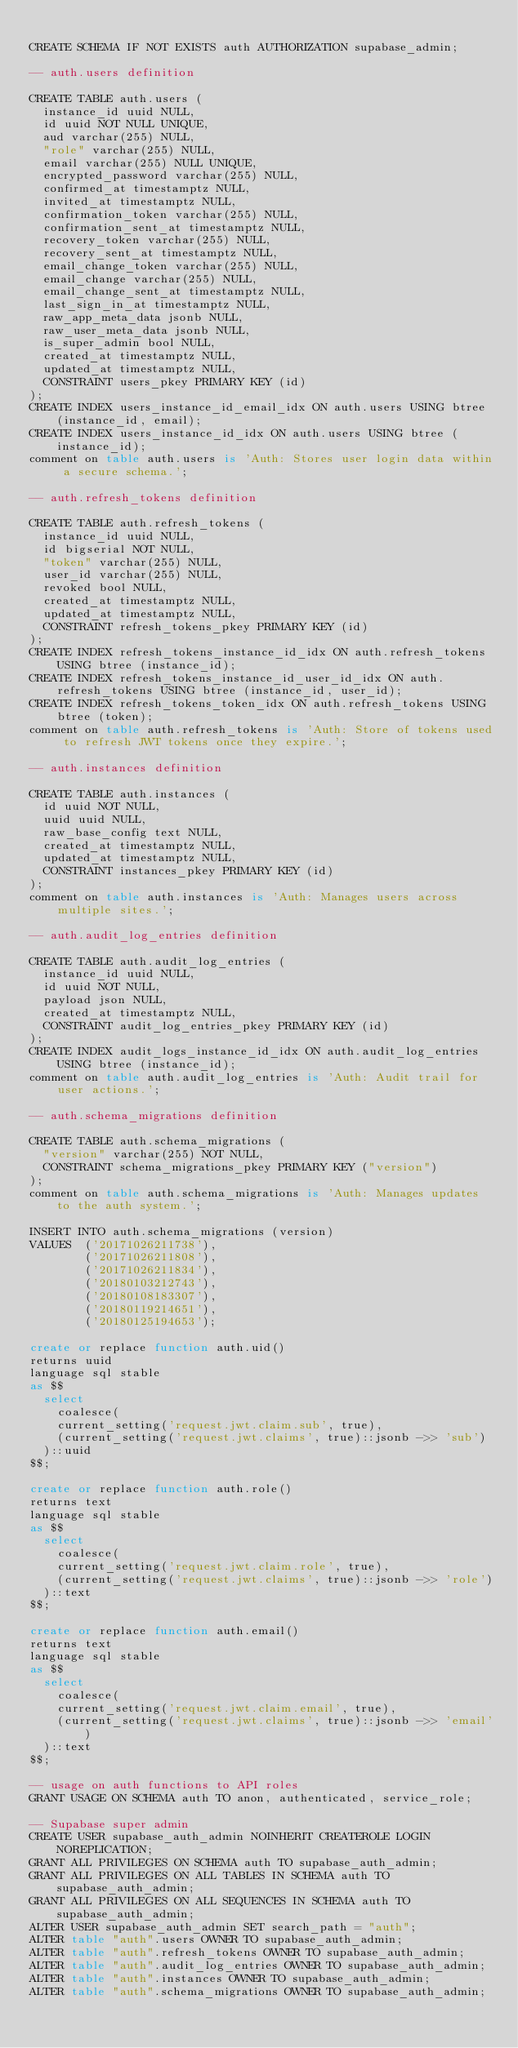<code> <loc_0><loc_0><loc_500><loc_500><_SQL_>
CREATE SCHEMA IF NOT EXISTS auth AUTHORIZATION supabase_admin;

-- auth.users definition

CREATE TABLE auth.users (
	instance_id uuid NULL,
	id uuid NOT NULL UNIQUE,
	aud varchar(255) NULL,
	"role" varchar(255) NULL,
	email varchar(255) NULL UNIQUE,
	encrypted_password varchar(255) NULL,
	confirmed_at timestamptz NULL,
	invited_at timestamptz NULL,
	confirmation_token varchar(255) NULL,
	confirmation_sent_at timestamptz NULL,
	recovery_token varchar(255) NULL,
	recovery_sent_at timestamptz NULL,
	email_change_token varchar(255) NULL,
	email_change varchar(255) NULL,
	email_change_sent_at timestamptz NULL,
	last_sign_in_at timestamptz NULL,
	raw_app_meta_data jsonb NULL,
	raw_user_meta_data jsonb NULL,
	is_super_admin bool NULL,
	created_at timestamptz NULL,
	updated_at timestamptz NULL,
	CONSTRAINT users_pkey PRIMARY KEY (id)
);
CREATE INDEX users_instance_id_email_idx ON auth.users USING btree (instance_id, email);
CREATE INDEX users_instance_id_idx ON auth.users USING btree (instance_id);
comment on table auth.users is 'Auth: Stores user login data within a secure schema.';

-- auth.refresh_tokens definition

CREATE TABLE auth.refresh_tokens (
	instance_id uuid NULL,
	id bigserial NOT NULL,
	"token" varchar(255) NULL,
	user_id varchar(255) NULL,
	revoked bool NULL,
	created_at timestamptz NULL,
	updated_at timestamptz NULL,
	CONSTRAINT refresh_tokens_pkey PRIMARY KEY (id)
);
CREATE INDEX refresh_tokens_instance_id_idx ON auth.refresh_tokens USING btree (instance_id);
CREATE INDEX refresh_tokens_instance_id_user_id_idx ON auth.refresh_tokens USING btree (instance_id, user_id);
CREATE INDEX refresh_tokens_token_idx ON auth.refresh_tokens USING btree (token);
comment on table auth.refresh_tokens is 'Auth: Store of tokens used to refresh JWT tokens once they expire.';

-- auth.instances definition

CREATE TABLE auth.instances (
	id uuid NOT NULL,
	uuid uuid NULL,
	raw_base_config text NULL,
	created_at timestamptz NULL,
	updated_at timestamptz NULL,
	CONSTRAINT instances_pkey PRIMARY KEY (id)
);
comment on table auth.instances is 'Auth: Manages users across multiple sites.';

-- auth.audit_log_entries definition

CREATE TABLE auth.audit_log_entries (
	instance_id uuid NULL,
	id uuid NOT NULL,
	payload json NULL,
	created_at timestamptz NULL,
	CONSTRAINT audit_log_entries_pkey PRIMARY KEY (id)
);
CREATE INDEX audit_logs_instance_id_idx ON auth.audit_log_entries USING btree (instance_id);
comment on table auth.audit_log_entries is 'Auth: Audit trail for user actions.';

-- auth.schema_migrations definition

CREATE TABLE auth.schema_migrations (
	"version" varchar(255) NOT NULL,
	CONSTRAINT schema_migrations_pkey PRIMARY KEY ("version")
);
comment on table auth.schema_migrations is 'Auth: Manages updates to the auth system.';

INSERT INTO auth.schema_migrations (version)
VALUES  ('20171026211738'),
        ('20171026211808'),
        ('20171026211834'),
        ('20180103212743'),
        ('20180108183307'),
        ('20180119214651'),
        ('20180125194653');

create or replace function auth.uid() 
returns uuid 
language sql stable
as $$
  select 
  	coalesce(
		current_setting('request.jwt.claim.sub', true),
		(current_setting('request.jwt.claims', true)::jsonb ->> 'sub')
	)::uuid
$$;

create or replace function auth.role() 
returns text 
language sql stable
as $$
  select 
  	coalesce(
		current_setting('request.jwt.claim.role', true),
		(current_setting('request.jwt.claims', true)::jsonb ->> 'role')
	)::text
$$;

create or replace function auth.email() 
returns text 
language sql stable
as $$
  select 
  	coalesce(
		current_setting('request.jwt.claim.email', true),
		(current_setting('request.jwt.claims', true)::jsonb ->> 'email')
	)::text
$$;

-- usage on auth functions to API roles
GRANT USAGE ON SCHEMA auth TO anon, authenticated, service_role;

-- Supabase super admin
CREATE USER supabase_auth_admin NOINHERIT CREATEROLE LOGIN NOREPLICATION;
GRANT ALL PRIVILEGES ON SCHEMA auth TO supabase_auth_admin;
GRANT ALL PRIVILEGES ON ALL TABLES IN SCHEMA auth TO supabase_auth_admin;
GRANT ALL PRIVILEGES ON ALL SEQUENCES IN SCHEMA auth TO supabase_auth_admin;
ALTER USER supabase_auth_admin SET search_path = "auth";
ALTER table "auth".users OWNER TO supabase_auth_admin;
ALTER table "auth".refresh_tokens OWNER TO supabase_auth_admin;
ALTER table "auth".audit_log_entries OWNER TO supabase_auth_admin;
ALTER table "auth".instances OWNER TO supabase_auth_admin;
ALTER table "auth".schema_migrations OWNER TO supabase_auth_admin;
</code> 